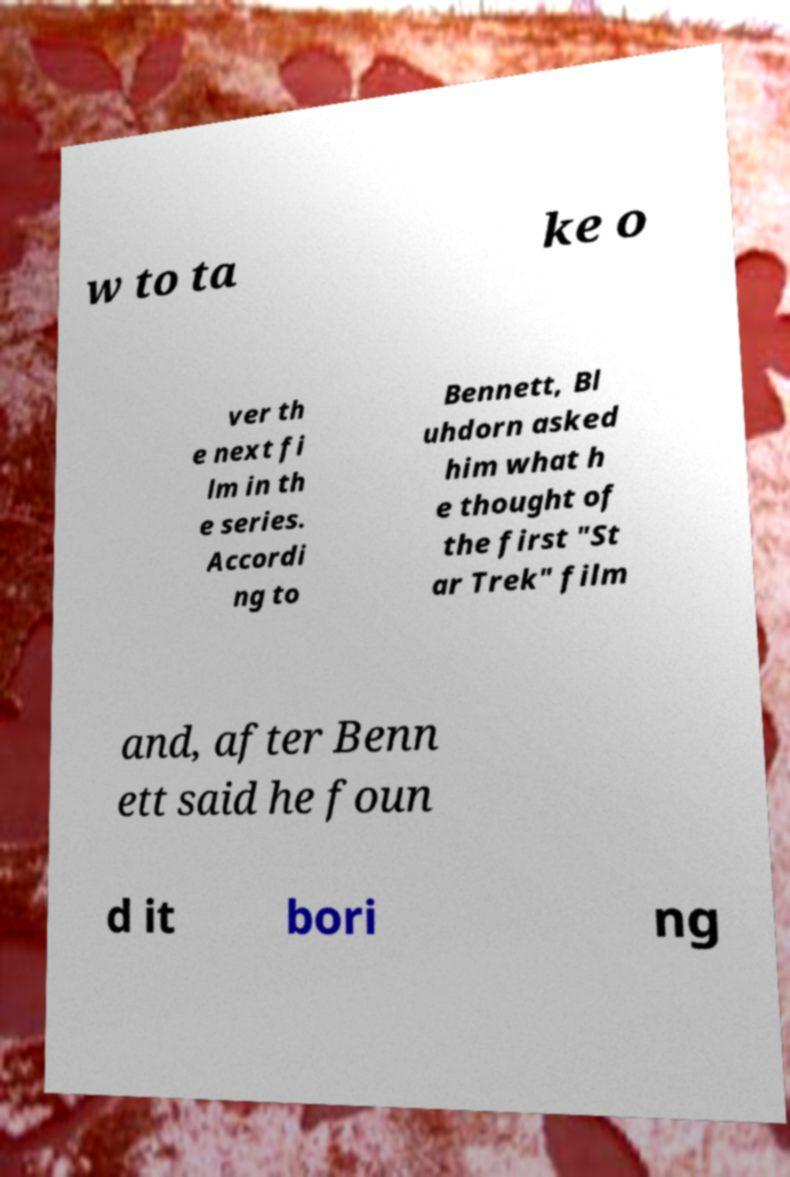Could you assist in decoding the text presented in this image and type it out clearly? w to ta ke o ver th e next fi lm in th e series. Accordi ng to Bennett, Bl uhdorn asked him what h e thought of the first "St ar Trek" film and, after Benn ett said he foun d it bori ng 